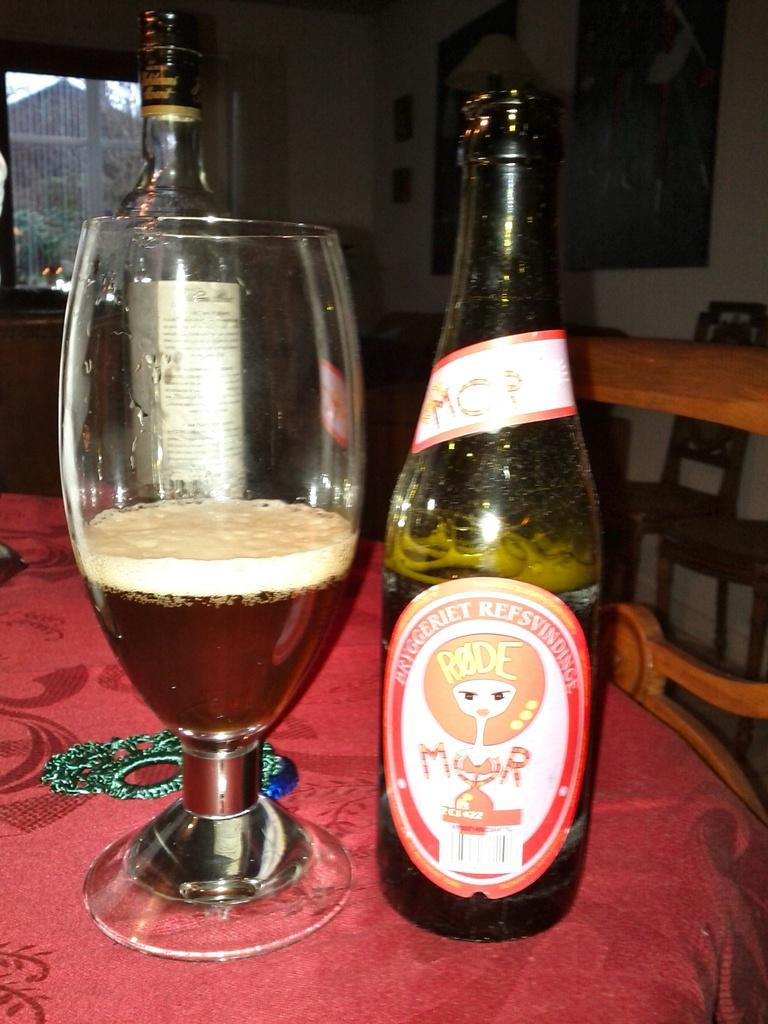<image>
Summarize the visual content of the image. A bottle of Bryggeriet Refsvindinge sits on a table next to a partially full glass. 